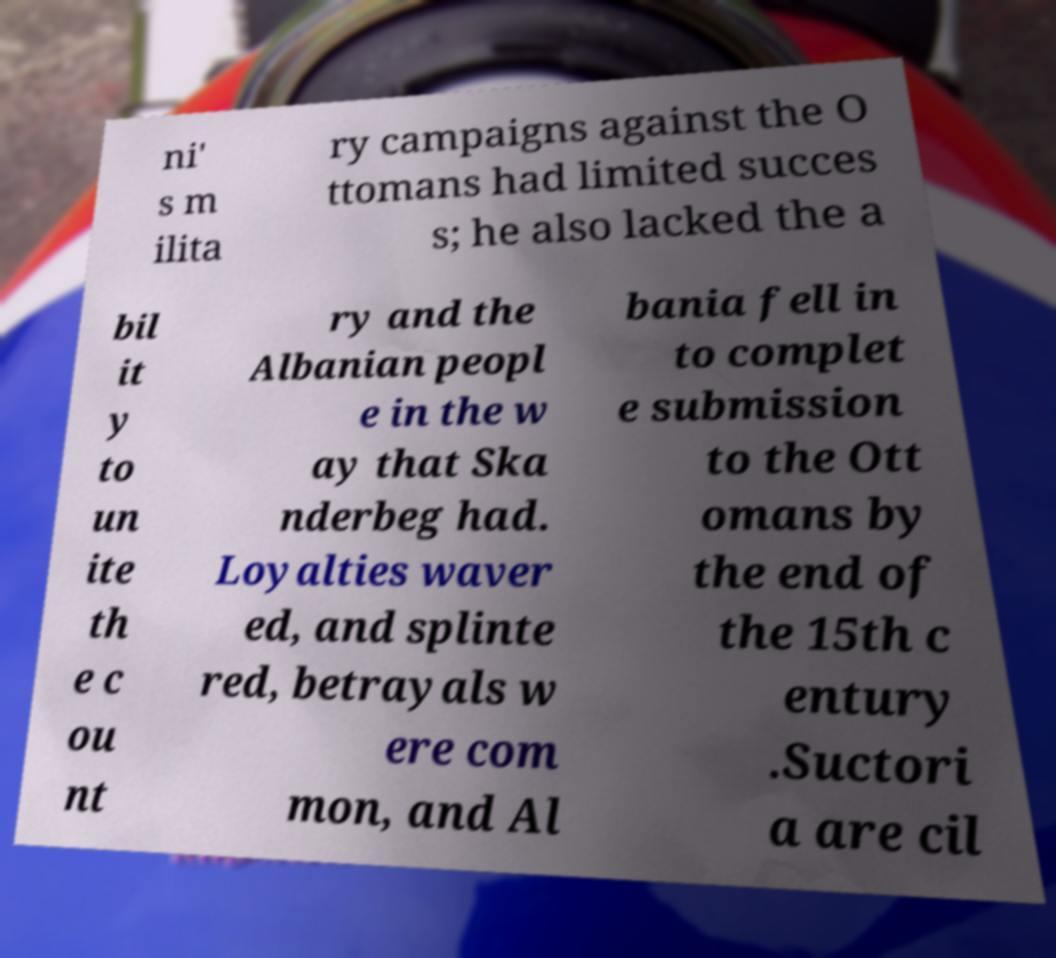Can you read and provide the text displayed in the image?This photo seems to have some interesting text. Can you extract and type it out for me? ni' s m ilita ry campaigns against the O ttomans had limited succes s; he also lacked the a bil it y to un ite th e c ou nt ry and the Albanian peopl e in the w ay that Ska nderbeg had. Loyalties waver ed, and splinte red, betrayals w ere com mon, and Al bania fell in to complet e submission to the Ott omans by the end of the 15th c entury .Suctori a are cil 